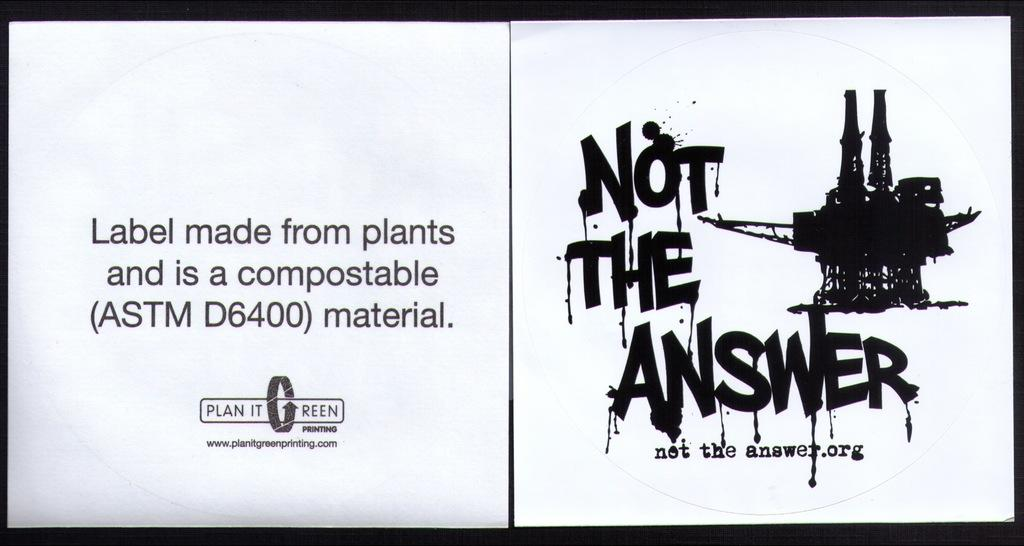What type of artwork is the image? The image is a collage. What elements can be found in the collage? There are letters and a drawing in the image. Can you describe the drawing in the collage? The drawing is black in color. What type of hospital is depicted in the image? There is no hospital depicted in the image; it is a collage containing letters and a black drawing. 